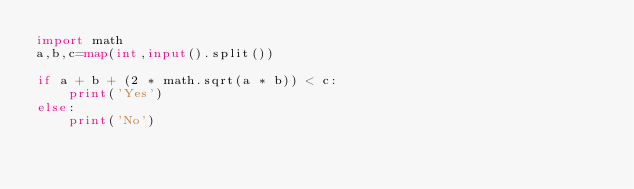<code> <loc_0><loc_0><loc_500><loc_500><_Python_>import math
a,b,c=map(int,input().split())

if a + b + (2 * math.sqrt(a * b)) < c:
    print('Yes')
else:
    print('No')</code> 